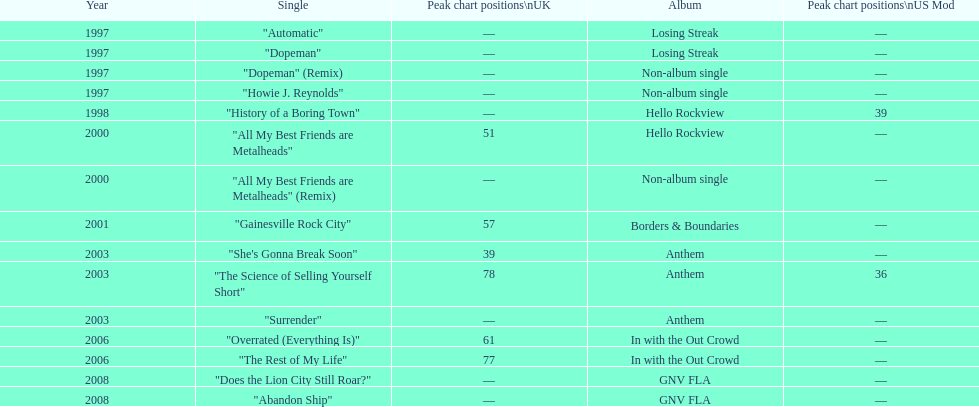Can you parse all the data within this table? {'header': ['Year', 'Single', 'Peak chart positions\\nUK', 'Album', 'Peak chart positions\\nUS Mod'], 'rows': [['1997', '"Automatic"', '—', 'Losing Streak', '—'], ['1997', '"Dopeman"', '—', 'Losing Streak', '—'], ['1997', '"Dopeman" (Remix)', '—', 'Non-album single', '—'], ['1997', '"Howie J. Reynolds"', '—', 'Non-album single', '—'], ['1998', '"History of a Boring Town"', '—', 'Hello Rockview', '39'], ['2000', '"All My Best Friends are Metalheads"', '51', 'Hello Rockview', '—'], ['2000', '"All My Best Friends are Metalheads" (Remix)', '—', 'Non-album single', '—'], ['2001', '"Gainesville Rock City"', '57', 'Borders & Boundaries', '—'], ['2003', '"She\'s Gonna Break Soon"', '39', 'Anthem', '—'], ['2003', '"The Science of Selling Yourself Short"', '78', 'Anthem', '36'], ['2003', '"Surrender"', '—', 'Anthem', '—'], ['2006', '"Overrated (Everything Is)"', '61', 'In with the Out Crowd', '—'], ['2006', '"The Rest of My Life"', '77', 'In with the Out Crowd', '—'], ['2008', '"Does the Lion City Still Roar?"', '—', 'GNV FLA', '—'], ['2008', '"Abandon Ship"', '—', 'GNV FLA', '—']]} Which year has the most singles? 1997. 